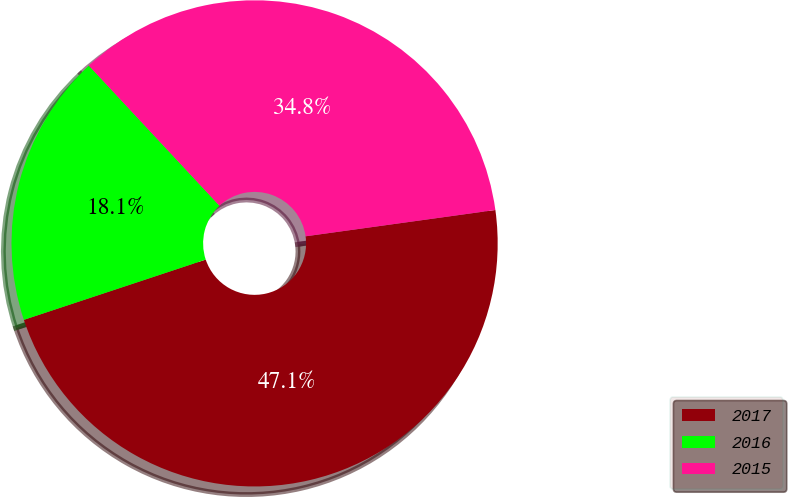<chart> <loc_0><loc_0><loc_500><loc_500><pie_chart><fcel>2017<fcel>2016<fcel>2015<nl><fcel>47.1%<fcel>18.15%<fcel>34.75%<nl></chart> 